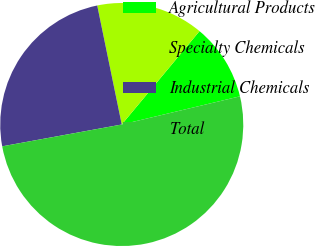Convert chart to OTSL. <chart><loc_0><loc_0><loc_500><loc_500><pie_chart><fcel>Agricultural Products<fcel>Specialty Chemicals<fcel>Industrial Chemicals<fcel>Total<nl><fcel>10.22%<fcel>14.29%<fcel>24.64%<fcel>50.85%<nl></chart> 